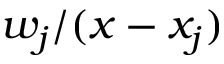<formula> <loc_0><loc_0><loc_500><loc_500>w _ { j } / ( x - x _ { j } )</formula> 